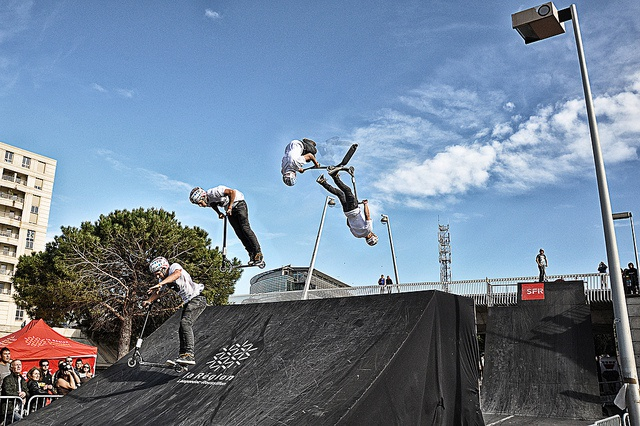Describe the objects in this image and their specific colors. I can see people in gray, black, white, and darkgray tones, people in gray, black, white, and lightblue tones, people in gray, black, lightblue, and lightgray tones, people in gray, black, darkgray, and lightgray tones, and people in gray, black, white, and darkgray tones in this image. 